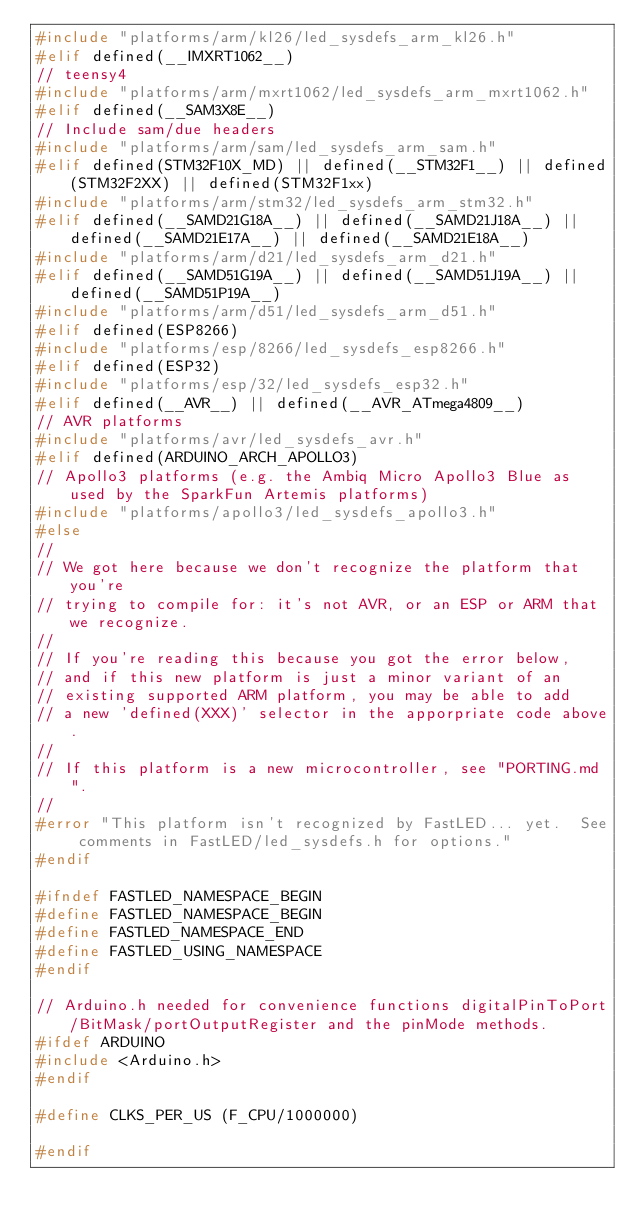Convert code to text. <code><loc_0><loc_0><loc_500><loc_500><_C_>#include "platforms/arm/kl26/led_sysdefs_arm_kl26.h"
#elif defined(__IMXRT1062__)
// teensy4
#include "platforms/arm/mxrt1062/led_sysdefs_arm_mxrt1062.h"
#elif defined(__SAM3X8E__)
// Include sam/due headers
#include "platforms/arm/sam/led_sysdefs_arm_sam.h"
#elif defined(STM32F10X_MD) || defined(__STM32F1__) || defined(STM32F2XX) || defined(STM32F1xx)
#include "platforms/arm/stm32/led_sysdefs_arm_stm32.h"
#elif defined(__SAMD21G18A__) || defined(__SAMD21J18A__) || defined(__SAMD21E17A__) || defined(__SAMD21E18A__) 
#include "platforms/arm/d21/led_sysdefs_arm_d21.h"
#elif defined(__SAMD51G19A__) || defined(__SAMD51J19A__) || defined(__SAMD51P19A__)
#include "platforms/arm/d51/led_sysdefs_arm_d51.h"
#elif defined(ESP8266)
#include "platforms/esp/8266/led_sysdefs_esp8266.h"
#elif defined(ESP32)
#include "platforms/esp/32/led_sysdefs_esp32.h"
#elif defined(__AVR__) || defined(__AVR_ATmega4809__)
// AVR platforms
#include "platforms/avr/led_sysdefs_avr.h"
#elif defined(ARDUINO_ARCH_APOLLO3)
// Apollo3 platforms (e.g. the Ambiq Micro Apollo3 Blue as used by the SparkFun Artemis platforms)
#include "platforms/apollo3/led_sysdefs_apollo3.h"
#else
//
// We got here because we don't recognize the platform that you're
// trying to compile for: it's not AVR, or an ESP or ARM that we recognize.
//
// If you're reading this because you got the error below,
// and if this new platform is just a minor variant of an
// existing supported ARM platform, you may be able to add
// a new 'defined(XXX)' selector in the apporpriate code above.
//
// If this platform is a new microcontroller, see "PORTING.md".
//
#error "This platform isn't recognized by FastLED... yet.  See comments in FastLED/led_sysdefs.h for options."
#endif

#ifndef FASTLED_NAMESPACE_BEGIN
#define FASTLED_NAMESPACE_BEGIN
#define FASTLED_NAMESPACE_END
#define FASTLED_USING_NAMESPACE
#endif

// Arduino.h needed for convenience functions digitalPinToPort/BitMask/portOutputRegister and the pinMode methods.
#ifdef ARDUINO
#include <Arduino.h>
#endif

#define CLKS_PER_US (F_CPU/1000000)

#endif
</code> 